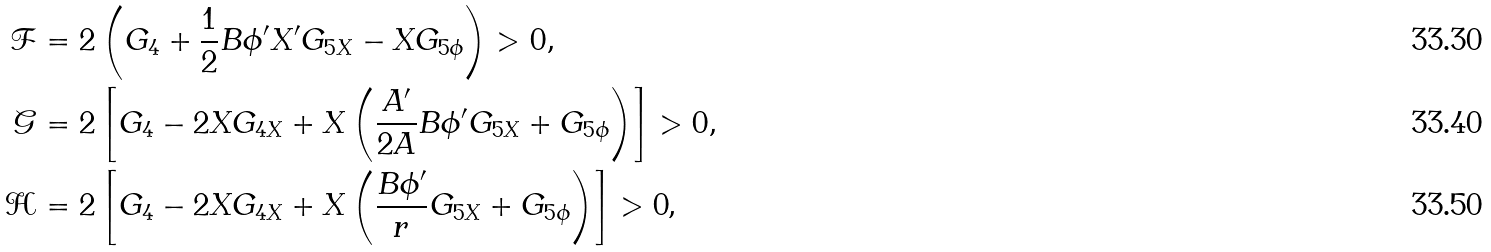Convert formula to latex. <formula><loc_0><loc_0><loc_500><loc_500>\mathcal { F } & = 2 \left ( G _ { 4 } + \frac { 1 } { 2 } B \phi ^ { \prime } X ^ { \prime } G _ { 5 X } - X G _ { 5 \phi } \right ) > 0 , \\ \mathcal { G } & = 2 \left [ G _ { 4 } - 2 X G _ { 4 X } + X \left ( \frac { A ^ { \prime } } { 2 A } B \phi ^ { \prime } G _ { 5 X } + G _ { 5 \phi } \right ) \right ] > 0 , \\ \mathcal { H } & = 2 \left [ G _ { 4 } - 2 X G _ { 4 X } + X \left ( \frac { B \phi ^ { \prime } } { r } G _ { 5 X } + G _ { 5 \phi } \right ) \right ] > 0 \text {,}</formula> 